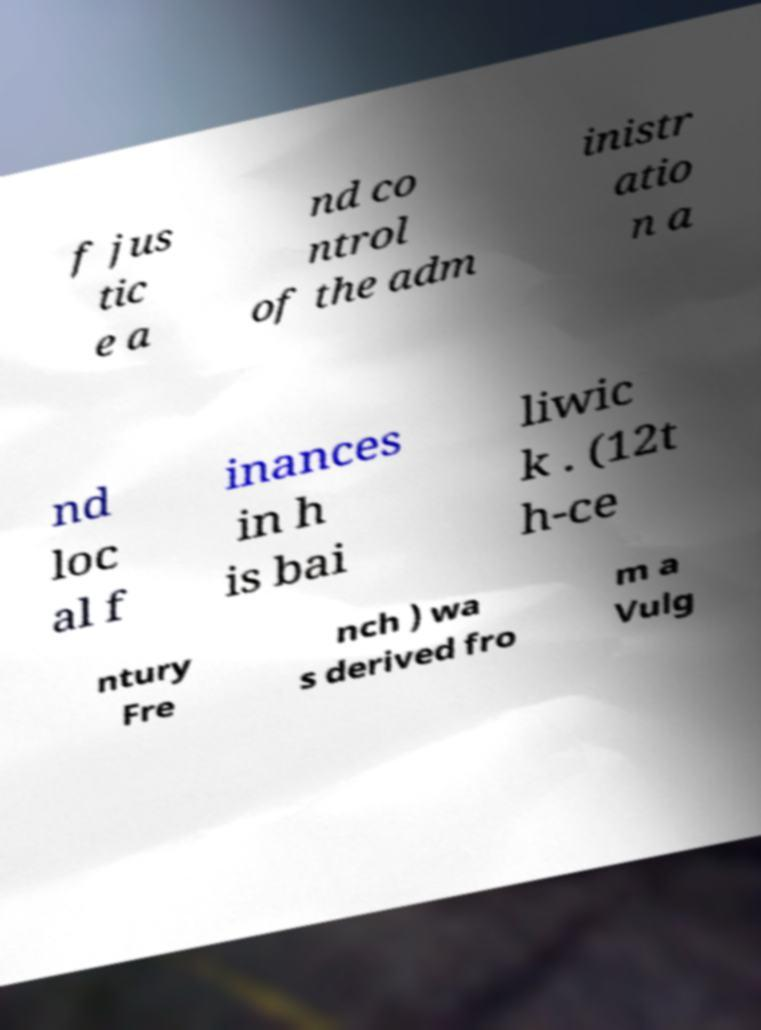I need the written content from this picture converted into text. Can you do that? f jus tic e a nd co ntrol of the adm inistr atio n a nd loc al f inances in h is bai liwic k . (12t h-ce ntury Fre nch ) wa s derived fro m a Vulg 